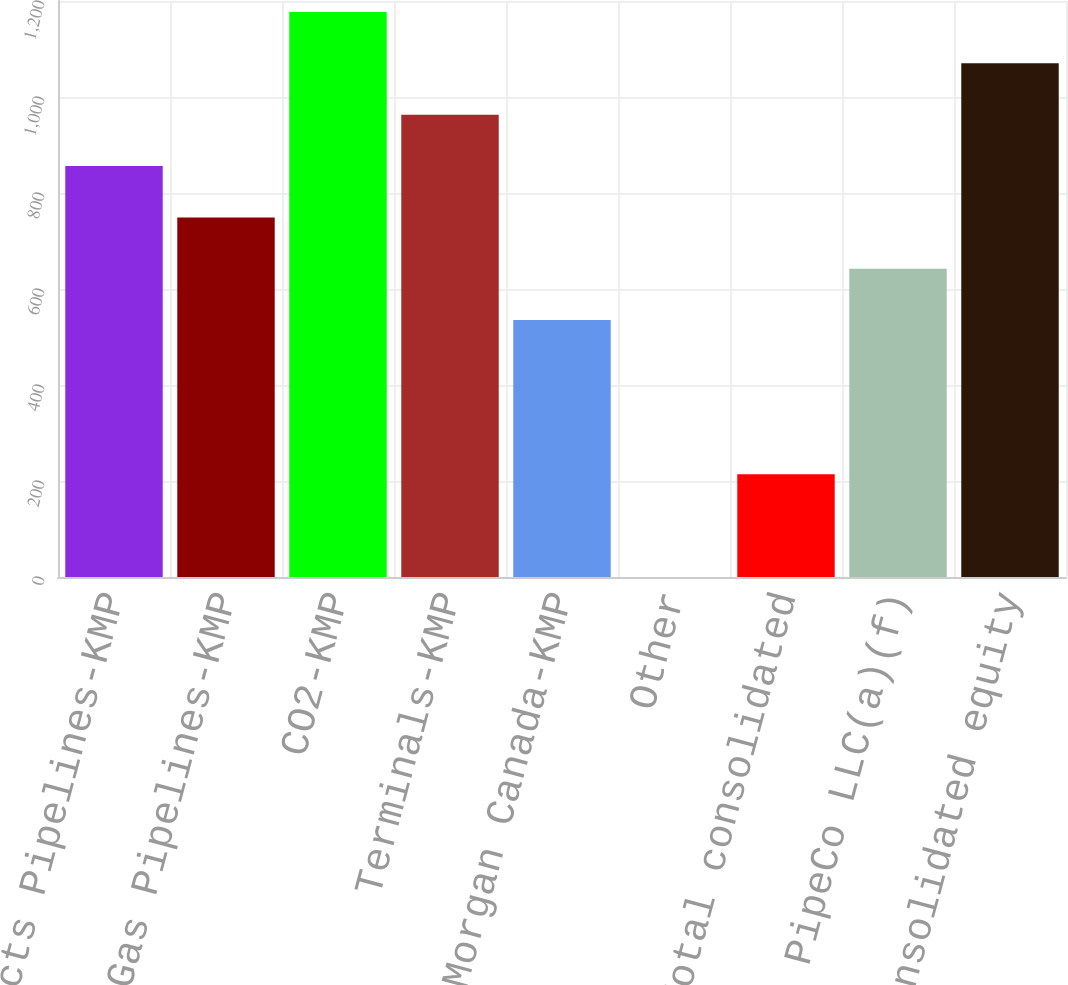Convert chart to OTSL. <chart><loc_0><loc_0><loc_500><loc_500><bar_chart><fcel>Products Pipelines-KMP<fcel>Natural Gas Pipelines-KMP<fcel>CO2-KMP<fcel>Terminals-KMP<fcel>Kinder Morgan Canada-KMP<fcel>Other<fcel>Total consolidated<fcel>NGPL PipeCo LLC(a)(f)<fcel>Total consolidated equity<nl><fcel>856.2<fcel>749.2<fcel>1177.2<fcel>963.2<fcel>535.2<fcel>0.2<fcel>214.2<fcel>642.2<fcel>1070.2<nl></chart> 